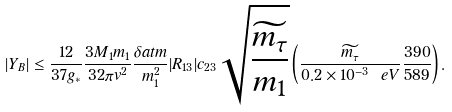Convert formula to latex. <formula><loc_0><loc_0><loc_500><loc_500>| Y _ { B } | \leq \frac { 1 2 } { 3 7 g _ { \ast } } \frac { 3 M _ { 1 } m _ { 1 } } { 3 2 \pi v ^ { 2 } } \frac { \delta a t m } { m _ { 1 } ^ { 2 } } | R _ { 1 3 } | c _ { 2 3 } \sqrt { \frac { \widetilde { m _ { \tau } } } { m _ { 1 } } } \left ( \frac { \widetilde { m _ { \tau } } } { 0 . 2 \times 1 0 ^ { - 3 } \ e V } \frac { 3 9 0 } { 5 8 9 } \right ) .</formula> 